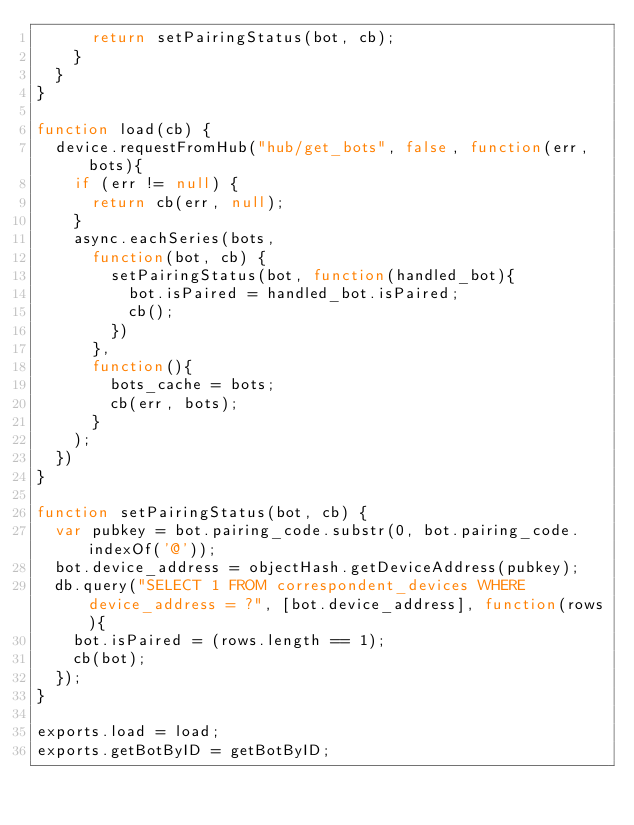Convert code to text. <code><loc_0><loc_0><loc_500><loc_500><_JavaScript_>			return setPairingStatus(bot, cb);
		}
	}
}

function load(cb) {
	device.requestFromHub("hub/get_bots", false, function(err, bots){
		if (err != null) {
			return cb(err, null);
		}
		async.eachSeries(bots, 
			function(bot, cb) {
				setPairingStatus(bot, function(handled_bot){
					bot.isPaired = handled_bot.isPaired;
					cb();
				})
			},
			function(){
				bots_cache = bots;
				cb(err, bots);
			}
		);
	})
}

function setPairingStatus(bot, cb) {
	var pubkey = bot.pairing_code.substr(0, bot.pairing_code.indexOf('@'));
	bot.device_address = objectHash.getDeviceAddress(pubkey);
	db.query("SELECT 1 FROM correspondent_devices WHERE device_address = ?", [bot.device_address], function(rows){
		bot.isPaired = (rows.length == 1);
		cb(bot);
	});
}

exports.load = load;
exports.getBotByID = getBotByID;


</code> 